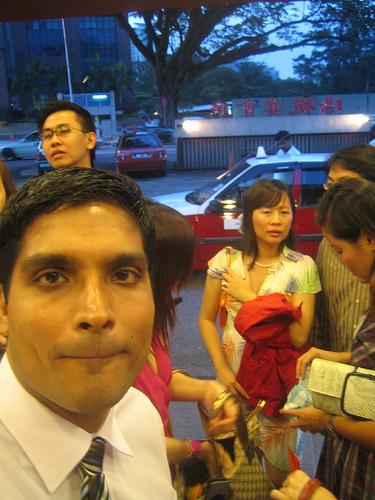What language is the sign in?
Keep it brief. Chinese. What color is the woman's jacket?
Give a very brief answer. Red. Is there a cab behind the people?
Write a very short answer. Yes. 